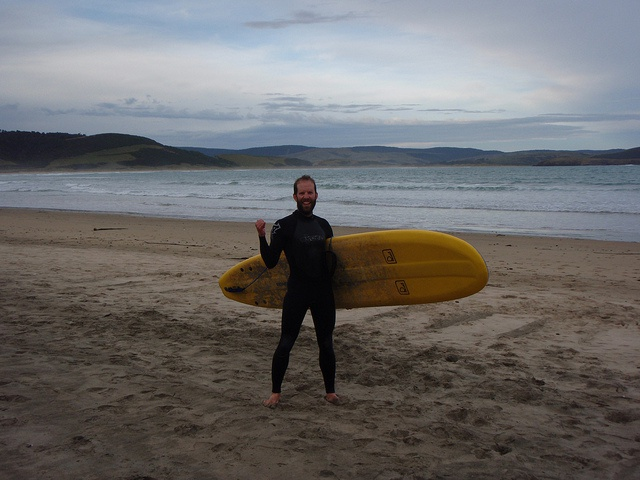Describe the objects in this image and their specific colors. I can see surfboard in darkgray, maroon, black, and olive tones and people in darkgray, black, maroon, and gray tones in this image. 